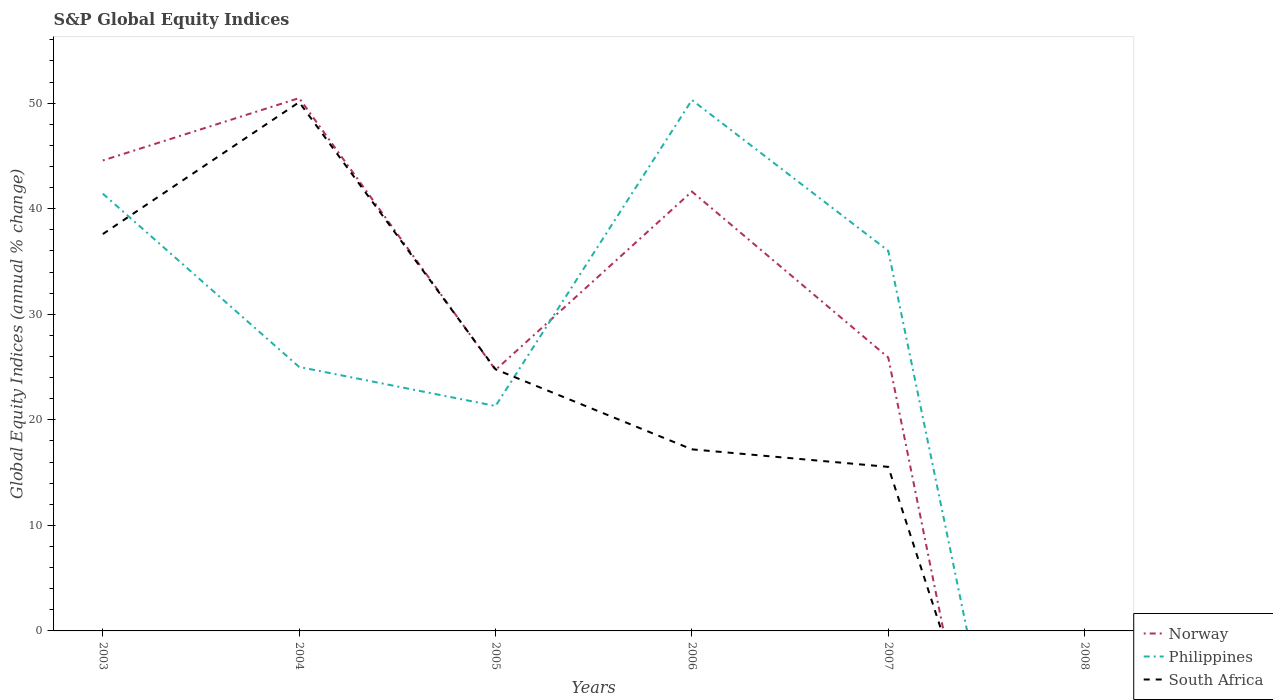How many different coloured lines are there?
Offer a terse response. 3. Does the line corresponding to Norway intersect with the line corresponding to South Africa?
Keep it short and to the point. Yes. Is the number of lines equal to the number of legend labels?
Ensure brevity in your answer.  No. What is the total global equity indices in Philippines in the graph?
Your response must be concise. -11.01. What is the difference between the highest and the second highest global equity indices in Norway?
Your answer should be compact. 50.49. How many years are there in the graph?
Offer a terse response. 6. Does the graph contain any zero values?
Provide a short and direct response. Yes. Does the graph contain grids?
Provide a succinct answer. No. Where does the legend appear in the graph?
Your answer should be compact. Bottom right. How many legend labels are there?
Give a very brief answer. 3. What is the title of the graph?
Offer a terse response. S&P Global Equity Indices. Does "Yemen, Rep." appear as one of the legend labels in the graph?
Offer a very short reply. No. What is the label or title of the Y-axis?
Offer a very short reply. Global Equity Indices (annual % change). What is the Global Equity Indices (annual % change) of Norway in 2003?
Provide a short and direct response. 44.57. What is the Global Equity Indices (annual % change) in Philippines in 2003?
Make the answer very short. 41.43. What is the Global Equity Indices (annual % change) of South Africa in 2003?
Give a very brief answer. 37.6. What is the Global Equity Indices (annual % change) of Norway in 2004?
Your answer should be compact. 50.49. What is the Global Equity Indices (annual % change) of Philippines in 2004?
Provide a succinct answer. 25.01. What is the Global Equity Indices (annual % change) in South Africa in 2004?
Make the answer very short. 50.1. What is the Global Equity Indices (annual % change) of Norway in 2005?
Ensure brevity in your answer.  24.73. What is the Global Equity Indices (annual % change) of Philippines in 2005?
Provide a short and direct response. 21.31. What is the Global Equity Indices (annual % change) of South Africa in 2005?
Your response must be concise. 24.79. What is the Global Equity Indices (annual % change) in Norway in 2006?
Offer a very short reply. 41.63. What is the Global Equity Indices (annual % change) in Philippines in 2006?
Make the answer very short. 50.3. What is the Global Equity Indices (annual % change) of South Africa in 2006?
Your response must be concise. 17.2. What is the Global Equity Indices (annual % change) in Norway in 2007?
Keep it short and to the point. 25.9. What is the Global Equity Indices (annual % change) of Philippines in 2007?
Offer a very short reply. 36.02. What is the Global Equity Indices (annual % change) in South Africa in 2007?
Make the answer very short. 15.54. What is the Global Equity Indices (annual % change) of Philippines in 2008?
Provide a short and direct response. 0. Across all years, what is the maximum Global Equity Indices (annual % change) of Norway?
Offer a very short reply. 50.49. Across all years, what is the maximum Global Equity Indices (annual % change) in Philippines?
Ensure brevity in your answer.  50.3. Across all years, what is the maximum Global Equity Indices (annual % change) in South Africa?
Give a very brief answer. 50.1. What is the total Global Equity Indices (annual % change) of Norway in the graph?
Provide a short and direct response. 187.32. What is the total Global Equity Indices (annual % change) of Philippines in the graph?
Provide a short and direct response. 174.07. What is the total Global Equity Indices (annual % change) in South Africa in the graph?
Your response must be concise. 145.23. What is the difference between the Global Equity Indices (annual % change) in Norway in 2003 and that in 2004?
Provide a short and direct response. -5.91. What is the difference between the Global Equity Indices (annual % change) in Philippines in 2003 and that in 2004?
Make the answer very short. 16.42. What is the difference between the Global Equity Indices (annual % change) in Norway in 2003 and that in 2005?
Ensure brevity in your answer.  19.85. What is the difference between the Global Equity Indices (annual % change) of Philippines in 2003 and that in 2005?
Keep it short and to the point. 20.12. What is the difference between the Global Equity Indices (annual % change) in South Africa in 2003 and that in 2005?
Ensure brevity in your answer.  12.81. What is the difference between the Global Equity Indices (annual % change) in Norway in 2003 and that in 2006?
Ensure brevity in your answer.  2.95. What is the difference between the Global Equity Indices (annual % change) in Philippines in 2003 and that in 2006?
Make the answer very short. -8.87. What is the difference between the Global Equity Indices (annual % change) of South Africa in 2003 and that in 2006?
Ensure brevity in your answer.  20.4. What is the difference between the Global Equity Indices (annual % change) of Norway in 2003 and that in 2007?
Ensure brevity in your answer.  18.67. What is the difference between the Global Equity Indices (annual % change) of Philippines in 2003 and that in 2007?
Your response must be concise. 5.41. What is the difference between the Global Equity Indices (annual % change) in South Africa in 2003 and that in 2007?
Give a very brief answer. 22.06. What is the difference between the Global Equity Indices (annual % change) in Norway in 2004 and that in 2005?
Your answer should be compact. 25.76. What is the difference between the Global Equity Indices (annual % change) in Philippines in 2004 and that in 2005?
Keep it short and to the point. 3.7. What is the difference between the Global Equity Indices (annual % change) in South Africa in 2004 and that in 2005?
Provide a short and direct response. 25.31. What is the difference between the Global Equity Indices (annual % change) in Norway in 2004 and that in 2006?
Your answer should be compact. 8.86. What is the difference between the Global Equity Indices (annual % change) in Philippines in 2004 and that in 2006?
Keep it short and to the point. -25.29. What is the difference between the Global Equity Indices (annual % change) of South Africa in 2004 and that in 2006?
Offer a terse response. 32.9. What is the difference between the Global Equity Indices (annual % change) of Norway in 2004 and that in 2007?
Make the answer very short. 24.58. What is the difference between the Global Equity Indices (annual % change) of Philippines in 2004 and that in 2007?
Make the answer very short. -11.01. What is the difference between the Global Equity Indices (annual % change) of South Africa in 2004 and that in 2007?
Keep it short and to the point. 34.56. What is the difference between the Global Equity Indices (annual % change) of Norway in 2005 and that in 2006?
Provide a succinct answer. -16.9. What is the difference between the Global Equity Indices (annual % change) in Philippines in 2005 and that in 2006?
Your answer should be compact. -28.99. What is the difference between the Global Equity Indices (annual % change) of South Africa in 2005 and that in 2006?
Provide a succinct answer. 7.58. What is the difference between the Global Equity Indices (annual % change) in Norway in 2005 and that in 2007?
Your response must be concise. -1.17. What is the difference between the Global Equity Indices (annual % change) of Philippines in 2005 and that in 2007?
Ensure brevity in your answer.  -14.7. What is the difference between the Global Equity Indices (annual % change) of South Africa in 2005 and that in 2007?
Provide a short and direct response. 9.24. What is the difference between the Global Equity Indices (annual % change) of Norway in 2006 and that in 2007?
Give a very brief answer. 15.73. What is the difference between the Global Equity Indices (annual % change) of Philippines in 2006 and that in 2007?
Your answer should be very brief. 14.29. What is the difference between the Global Equity Indices (annual % change) of South Africa in 2006 and that in 2007?
Your answer should be compact. 1.66. What is the difference between the Global Equity Indices (annual % change) in Norway in 2003 and the Global Equity Indices (annual % change) in Philippines in 2004?
Provide a short and direct response. 19.56. What is the difference between the Global Equity Indices (annual % change) in Norway in 2003 and the Global Equity Indices (annual % change) in South Africa in 2004?
Your answer should be compact. -5.53. What is the difference between the Global Equity Indices (annual % change) in Philippines in 2003 and the Global Equity Indices (annual % change) in South Africa in 2004?
Make the answer very short. -8.67. What is the difference between the Global Equity Indices (annual % change) of Norway in 2003 and the Global Equity Indices (annual % change) of Philippines in 2005?
Your response must be concise. 23.26. What is the difference between the Global Equity Indices (annual % change) in Norway in 2003 and the Global Equity Indices (annual % change) in South Africa in 2005?
Your answer should be compact. 19.79. What is the difference between the Global Equity Indices (annual % change) of Philippines in 2003 and the Global Equity Indices (annual % change) of South Africa in 2005?
Provide a succinct answer. 16.64. What is the difference between the Global Equity Indices (annual % change) of Norway in 2003 and the Global Equity Indices (annual % change) of Philippines in 2006?
Make the answer very short. -5.73. What is the difference between the Global Equity Indices (annual % change) in Norway in 2003 and the Global Equity Indices (annual % change) in South Africa in 2006?
Offer a very short reply. 27.37. What is the difference between the Global Equity Indices (annual % change) of Philippines in 2003 and the Global Equity Indices (annual % change) of South Africa in 2006?
Ensure brevity in your answer.  24.23. What is the difference between the Global Equity Indices (annual % change) in Norway in 2003 and the Global Equity Indices (annual % change) in Philippines in 2007?
Provide a succinct answer. 8.56. What is the difference between the Global Equity Indices (annual % change) in Norway in 2003 and the Global Equity Indices (annual % change) in South Africa in 2007?
Your response must be concise. 29.03. What is the difference between the Global Equity Indices (annual % change) in Philippines in 2003 and the Global Equity Indices (annual % change) in South Africa in 2007?
Your response must be concise. 25.89. What is the difference between the Global Equity Indices (annual % change) of Norway in 2004 and the Global Equity Indices (annual % change) of Philippines in 2005?
Provide a short and direct response. 29.18. What is the difference between the Global Equity Indices (annual % change) of Norway in 2004 and the Global Equity Indices (annual % change) of South Africa in 2005?
Give a very brief answer. 25.7. What is the difference between the Global Equity Indices (annual % change) of Philippines in 2004 and the Global Equity Indices (annual % change) of South Africa in 2005?
Offer a very short reply. 0.22. What is the difference between the Global Equity Indices (annual % change) in Norway in 2004 and the Global Equity Indices (annual % change) in Philippines in 2006?
Offer a very short reply. 0.18. What is the difference between the Global Equity Indices (annual % change) in Norway in 2004 and the Global Equity Indices (annual % change) in South Africa in 2006?
Give a very brief answer. 33.28. What is the difference between the Global Equity Indices (annual % change) in Philippines in 2004 and the Global Equity Indices (annual % change) in South Africa in 2006?
Keep it short and to the point. 7.81. What is the difference between the Global Equity Indices (annual % change) of Norway in 2004 and the Global Equity Indices (annual % change) of Philippines in 2007?
Your answer should be very brief. 14.47. What is the difference between the Global Equity Indices (annual % change) of Norway in 2004 and the Global Equity Indices (annual % change) of South Africa in 2007?
Provide a succinct answer. 34.94. What is the difference between the Global Equity Indices (annual % change) of Philippines in 2004 and the Global Equity Indices (annual % change) of South Africa in 2007?
Give a very brief answer. 9.47. What is the difference between the Global Equity Indices (annual % change) of Norway in 2005 and the Global Equity Indices (annual % change) of Philippines in 2006?
Offer a very short reply. -25.57. What is the difference between the Global Equity Indices (annual % change) of Norway in 2005 and the Global Equity Indices (annual % change) of South Africa in 2006?
Offer a very short reply. 7.52. What is the difference between the Global Equity Indices (annual % change) of Philippines in 2005 and the Global Equity Indices (annual % change) of South Africa in 2006?
Your answer should be compact. 4.11. What is the difference between the Global Equity Indices (annual % change) of Norway in 2005 and the Global Equity Indices (annual % change) of Philippines in 2007?
Offer a very short reply. -11.29. What is the difference between the Global Equity Indices (annual % change) of Norway in 2005 and the Global Equity Indices (annual % change) of South Africa in 2007?
Provide a short and direct response. 9.19. What is the difference between the Global Equity Indices (annual % change) in Philippines in 2005 and the Global Equity Indices (annual % change) in South Africa in 2007?
Offer a very short reply. 5.77. What is the difference between the Global Equity Indices (annual % change) of Norway in 2006 and the Global Equity Indices (annual % change) of Philippines in 2007?
Offer a very short reply. 5.61. What is the difference between the Global Equity Indices (annual % change) of Norway in 2006 and the Global Equity Indices (annual % change) of South Africa in 2007?
Your response must be concise. 26.09. What is the difference between the Global Equity Indices (annual % change) of Philippines in 2006 and the Global Equity Indices (annual % change) of South Africa in 2007?
Your answer should be compact. 34.76. What is the average Global Equity Indices (annual % change) of Norway per year?
Offer a very short reply. 31.22. What is the average Global Equity Indices (annual % change) in Philippines per year?
Your answer should be compact. 29.01. What is the average Global Equity Indices (annual % change) of South Africa per year?
Keep it short and to the point. 24.21. In the year 2003, what is the difference between the Global Equity Indices (annual % change) in Norway and Global Equity Indices (annual % change) in Philippines?
Make the answer very short. 3.14. In the year 2003, what is the difference between the Global Equity Indices (annual % change) in Norway and Global Equity Indices (annual % change) in South Africa?
Offer a terse response. 6.97. In the year 2003, what is the difference between the Global Equity Indices (annual % change) in Philippines and Global Equity Indices (annual % change) in South Africa?
Provide a succinct answer. 3.83. In the year 2004, what is the difference between the Global Equity Indices (annual % change) of Norway and Global Equity Indices (annual % change) of Philippines?
Provide a short and direct response. 25.48. In the year 2004, what is the difference between the Global Equity Indices (annual % change) of Norway and Global Equity Indices (annual % change) of South Africa?
Your answer should be compact. 0.39. In the year 2004, what is the difference between the Global Equity Indices (annual % change) in Philippines and Global Equity Indices (annual % change) in South Africa?
Your answer should be compact. -25.09. In the year 2005, what is the difference between the Global Equity Indices (annual % change) in Norway and Global Equity Indices (annual % change) in Philippines?
Give a very brief answer. 3.42. In the year 2005, what is the difference between the Global Equity Indices (annual % change) of Norway and Global Equity Indices (annual % change) of South Africa?
Your response must be concise. -0.06. In the year 2005, what is the difference between the Global Equity Indices (annual % change) of Philippines and Global Equity Indices (annual % change) of South Africa?
Ensure brevity in your answer.  -3.48. In the year 2006, what is the difference between the Global Equity Indices (annual % change) in Norway and Global Equity Indices (annual % change) in Philippines?
Provide a succinct answer. -8.67. In the year 2006, what is the difference between the Global Equity Indices (annual % change) of Norway and Global Equity Indices (annual % change) of South Africa?
Keep it short and to the point. 24.42. In the year 2006, what is the difference between the Global Equity Indices (annual % change) in Philippines and Global Equity Indices (annual % change) in South Africa?
Provide a succinct answer. 33.1. In the year 2007, what is the difference between the Global Equity Indices (annual % change) in Norway and Global Equity Indices (annual % change) in Philippines?
Give a very brief answer. -10.11. In the year 2007, what is the difference between the Global Equity Indices (annual % change) in Norway and Global Equity Indices (annual % change) in South Africa?
Offer a terse response. 10.36. In the year 2007, what is the difference between the Global Equity Indices (annual % change) of Philippines and Global Equity Indices (annual % change) of South Africa?
Offer a terse response. 20.47. What is the ratio of the Global Equity Indices (annual % change) of Norway in 2003 to that in 2004?
Provide a short and direct response. 0.88. What is the ratio of the Global Equity Indices (annual % change) in Philippines in 2003 to that in 2004?
Your answer should be very brief. 1.66. What is the ratio of the Global Equity Indices (annual % change) of South Africa in 2003 to that in 2004?
Provide a short and direct response. 0.75. What is the ratio of the Global Equity Indices (annual % change) in Norway in 2003 to that in 2005?
Your response must be concise. 1.8. What is the ratio of the Global Equity Indices (annual % change) in Philippines in 2003 to that in 2005?
Give a very brief answer. 1.94. What is the ratio of the Global Equity Indices (annual % change) in South Africa in 2003 to that in 2005?
Your answer should be compact. 1.52. What is the ratio of the Global Equity Indices (annual % change) of Norway in 2003 to that in 2006?
Provide a short and direct response. 1.07. What is the ratio of the Global Equity Indices (annual % change) of Philippines in 2003 to that in 2006?
Provide a succinct answer. 0.82. What is the ratio of the Global Equity Indices (annual % change) of South Africa in 2003 to that in 2006?
Your answer should be very brief. 2.19. What is the ratio of the Global Equity Indices (annual % change) in Norway in 2003 to that in 2007?
Give a very brief answer. 1.72. What is the ratio of the Global Equity Indices (annual % change) in Philippines in 2003 to that in 2007?
Your answer should be compact. 1.15. What is the ratio of the Global Equity Indices (annual % change) of South Africa in 2003 to that in 2007?
Ensure brevity in your answer.  2.42. What is the ratio of the Global Equity Indices (annual % change) of Norway in 2004 to that in 2005?
Offer a very short reply. 2.04. What is the ratio of the Global Equity Indices (annual % change) of Philippines in 2004 to that in 2005?
Ensure brevity in your answer.  1.17. What is the ratio of the Global Equity Indices (annual % change) in South Africa in 2004 to that in 2005?
Your answer should be very brief. 2.02. What is the ratio of the Global Equity Indices (annual % change) of Norway in 2004 to that in 2006?
Ensure brevity in your answer.  1.21. What is the ratio of the Global Equity Indices (annual % change) of Philippines in 2004 to that in 2006?
Provide a succinct answer. 0.5. What is the ratio of the Global Equity Indices (annual % change) in South Africa in 2004 to that in 2006?
Offer a very short reply. 2.91. What is the ratio of the Global Equity Indices (annual % change) in Norway in 2004 to that in 2007?
Keep it short and to the point. 1.95. What is the ratio of the Global Equity Indices (annual % change) of Philippines in 2004 to that in 2007?
Ensure brevity in your answer.  0.69. What is the ratio of the Global Equity Indices (annual % change) in South Africa in 2004 to that in 2007?
Offer a very short reply. 3.22. What is the ratio of the Global Equity Indices (annual % change) in Norway in 2005 to that in 2006?
Provide a succinct answer. 0.59. What is the ratio of the Global Equity Indices (annual % change) of Philippines in 2005 to that in 2006?
Your answer should be very brief. 0.42. What is the ratio of the Global Equity Indices (annual % change) of South Africa in 2005 to that in 2006?
Make the answer very short. 1.44. What is the ratio of the Global Equity Indices (annual % change) in Norway in 2005 to that in 2007?
Keep it short and to the point. 0.95. What is the ratio of the Global Equity Indices (annual % change) in Philippines in 2005 to that in 2007?
Your answer should be compact. 0.59. What is the ratio of the Global Equity Indices (annual % change) of South Africa in 2005 to that in 2007?
Make the answer very short. 1.59. What is the ratio of the Global Equity Indices (annual % change) in Norway in 2006 to that in 2007?
Your answer should be very brief. 1.61. What is the ratio of the Global Equity Indices (annual % change) of Philippines in 2006 to that in 2007?
Offer a very short reply. 1.4. What is the ratio of the Global Equity Indices (annual % change) in South Africa in 2006 to that in 2007?
Provide a succinct answer. 1.11. What is the difference between the highest and the second highest Global Equity Indices (annual % change) in Norway?
Provide a succinct answer. 5.91. What is the difference between the highest and the second highest Global Equity Indices (annual % change) of Philippines?
Make the answer very short. 8.87. What is the difference between the highest and the second highest Global Equity Indices (annual % change) in South Africa?
Provide a succinct answer. 12.5. What is the difference between the highest and the lowest Global Equity Indices (annual % change) in Norway?
Provide a short and direct response. 50.49. What is the difference between the highest and the lowest Global Equity Indices (annual % change) in Philippines?
Offer a very short reply. 50.3. What is the difference between the highest and the lowest Global Equity Indices (annual % change) of South Africa?
Make the answer very short. 50.1. 